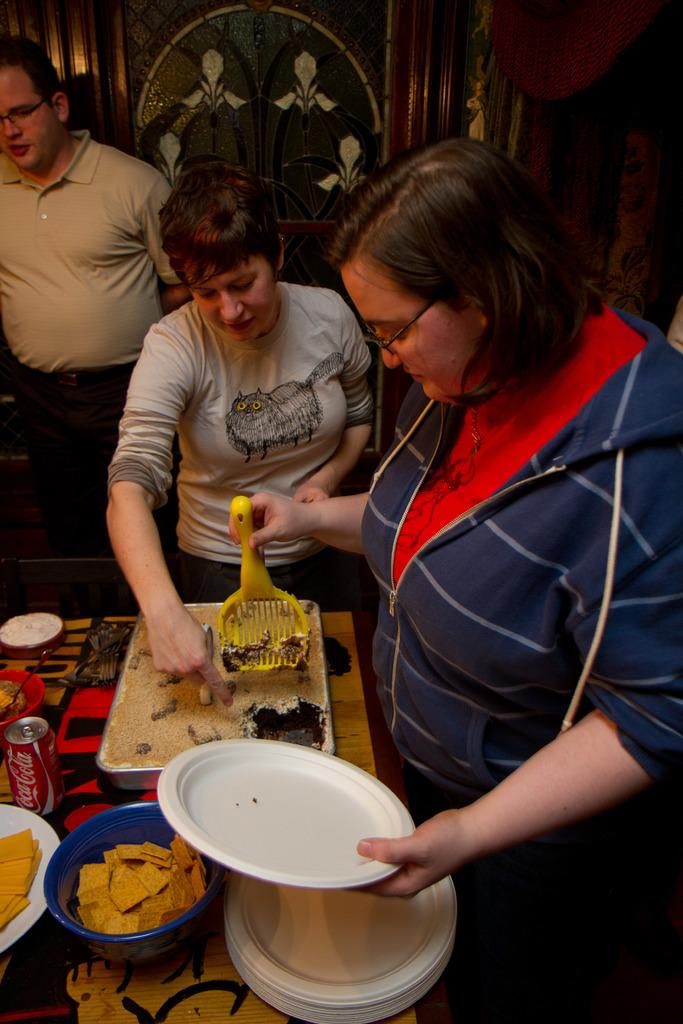What is happening in the image? There are people standing in the image. What is the woman holding in her hand? The woman is holding plates in her hand. What type of containers are present in the image that hold food items? There is a bowl and a vessel that hold food items. How many fangs can be seen on the people in the image? There are no fangs visible on the people in the image, as they are not animals with fangs. 